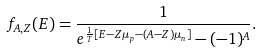Convert formula to latex. <formula><loc_0><loc_0><loc_500><loc_500>f _ { A , Z } ( E ) = \frac { 1 } { e ^ { \frac { 1 } { T } [ E - Z \mu _ { p } - ( A - Z ) \mu _ { n } ] } - ( - 1 ) ^ { A } } .</formula> 